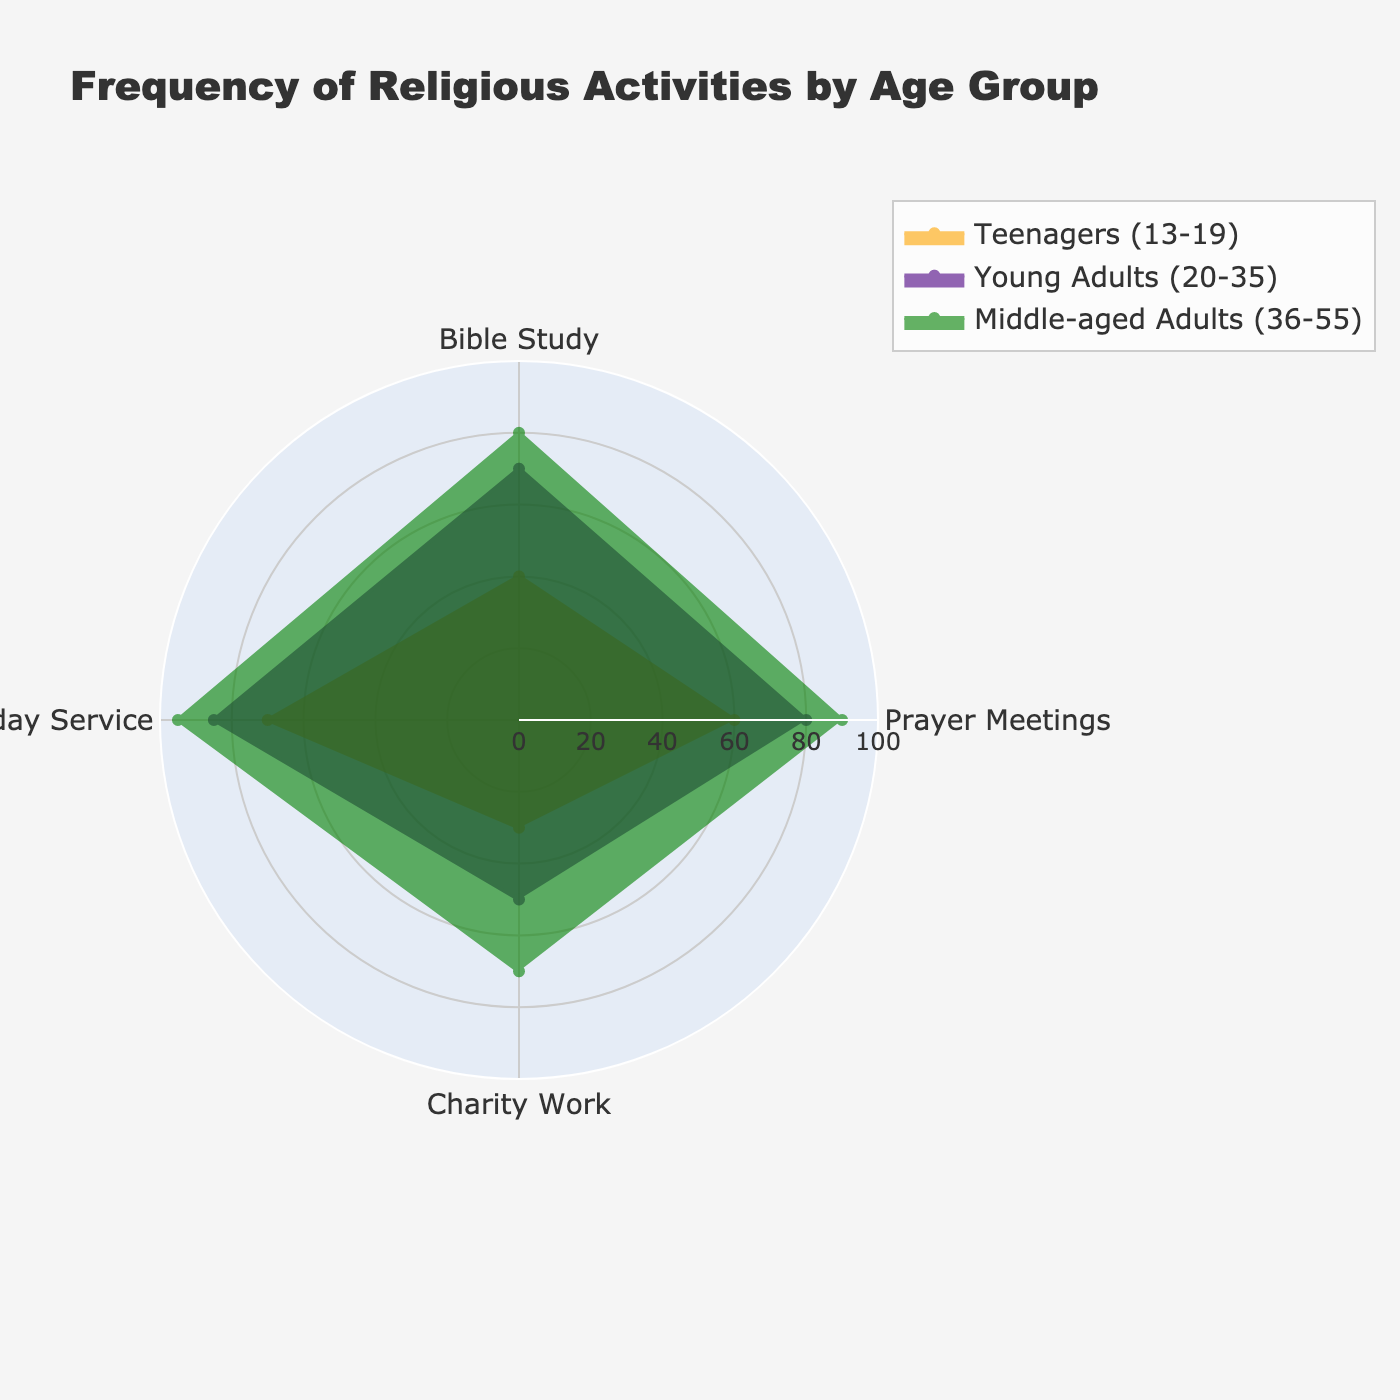What is the title of the radar chart? The title of the radar chart is shown at the top, highlighting the overall topic of the visualization.
Answer: Frequency of Religious Activities by Age Group How many age groups are compared in the radar chart? By looking at the colored areas and the legend, the chart compares three distinct age groups.
Answer: 3 Which age group participates the most in Charity Work? By comparing the values in the radial axis for Charity Work, the middle-colored segment, which corresponds to the Elderly group, extends the furthest.
Answer: Elderly (55+) Which age group has the highest frequency of Prayer Meetings? By checking the radial axis for the Prayer Meetings, we see that the second farthest colored segment belongs to Young Adults.
Answer: Middle-aged Adults (36-55) Which activity do Teenagers (13-19) participate in the most frequently? We look at all the radial values within the Teenagers group; the longest segment indicates the highest participation.
Answer: Sunday Service What is the difference in Bible Study frequency between Young Adults and Teenagers? By subtracting the Teenagers' value for Bible Study from the Young Adults' value (70 - 40).
Answer: 30 How does the frequency of Sunday Service for Elderly compare to that of Young Adults? The radial segment for Elderly extends further than that for Young Adults in Sunday Service.
Answer: Elderly is higher What is the average frequency of Bible Study across all groups? Sum the Bible Study values for all groups (40+70+80+85) and divide by 4.
Answer: 68.75 Which age group has the most balanced participation across all activities? By visually inspecting the chart, the group with the most similar length of segments across different activities appears more balanced.
Answer: Middle-aged Adults (36-55) Which group has the lowest participation in Charity Work? By checking the radial axis for Charity Work, we see the shortest segment belongs to Teenagers.
Answer: Teenagers (13-19) 